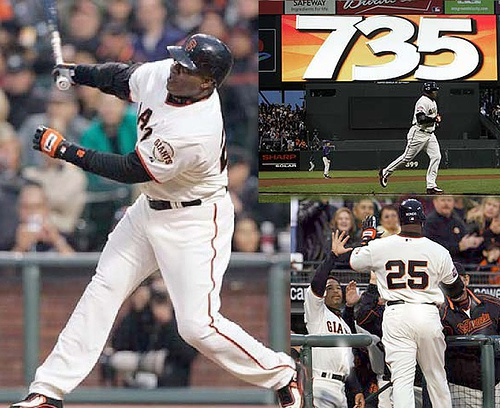Describe the objects in this image and their specific colors. I can see people in salmon, lightgray, black, darkgray, and gray tones, people in salmon, white, black, darkgray, and gray tones, people in salmon, lightgray, black, darkgray, and gray tones, people in salmon, darkgray, gray, and tan tones, and people in salmon, black, lightgray, darkgray, and gray tones in this image. 